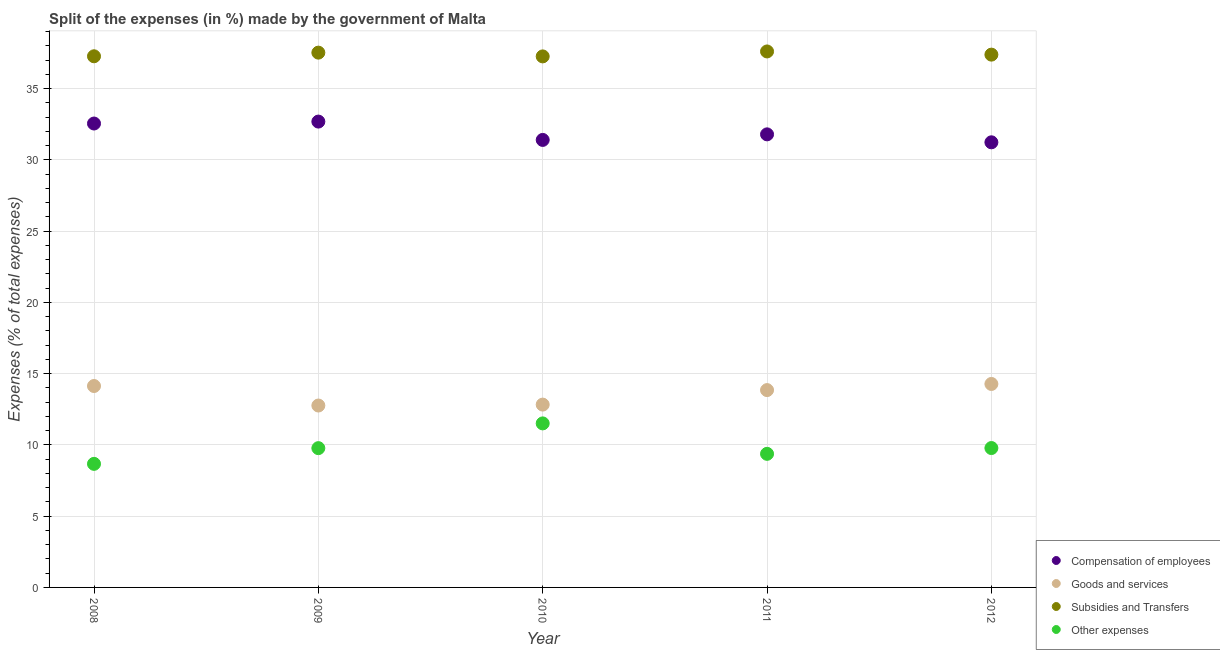How many different coloured dotlines are there?
Offer a terse response. 4. What is the percentage of amount spent on subsidies in 2012?
Provide a short and direct response. 37.38. Across all years, what is the maximum percentage of amount spent on goods and services?
Ensure brevity in your answer.  14.28. Across all years, what is the minimum percentage of amount spent on compensation of employees?
Provide a short and direct response. 31.23. In which year was the percentage of amount spent on subsidies maximum?
Your response must be concise. 2011. What is the total percentage of amount spent on goods and services in the graph?
Offer a very short reply. 67.84. What is the difference between the percentage of amount spent on goods and services in 2010 and that in 2012?
Keep it short and to the point. -1.45. What is the difference between the percentage of amount spent on subsidies in 2008 and the percentage of amount spent on other expenses in 2009?
Keep it short and to the point. 27.49. What is the average percentage of amount spent on compensation of employees per year?
Provide a succinct answer. 31.93. In the year 2011, what is the difference between the percentage of amount spent on other expenses and percentage of amount spent on goods and services?
Ensure brevity in your answer.  -4.47. What is the ratio of the percentage of amount spent on other expenses in 2008 to that in 2011?
Offer a terse response. 0.93. Is the percentage of amount spent on goods and services in 2008 less than that in 2012?
Your answer should be compact. Yes. Is the difference between the percentage of amount spent on compensation of employees in 2008 and 2009 greater than the difference between the percentage of amount spent on subsidies in 2008 and 2009?
Give a very brief answer. Yes. What is the difference between the highest and the second highest percentage of amount spent on other expenses?
Keep it short and to the point. 1.73. What is the difference between the highest and the lowest percentage of amount spent on subsidies?
Ensure brevity in your answer.  0.35. How many years are there in the graph?
Provide a short and direct response. 5. Does the graph contain grids?
Offer a terse response. Yes. What is the title of the graph?
Give a very brief answer. Split of the expenses (in %) made by the government of Malta. What is the label or title of the Y-axis?
Make the answer very short. Expenses (% of total expenses). What is the Expenses (% of total expenses) in Compensation of employees in 2008?
Offer a very short reply. 32.55. What is the Expenses (% of total expenses) in Goods and services in 2008?
Offer a terse response. 14.13. What is the Expenses (% of total expenses) in Subsidies and Transfers in 2008?
Ensure brevity in your answer.  37.27. What is the Expenses (% of total expenses) of Other expenses in 2008?
Your answer should be compact. 8.67. What is the Expenses (% of total expenses) in Compensation of employees in 2009?
Provide a succinct answer. 32.69. What is the Expenses (% of total expenses) of Goods and services in 2009?
Provide a succinct answer. 12.76. What is the Expenses (% of total expenses) in Subsidies and Transfers in 2009?
Provide a succinct answer. 37.52. What is the Expenses (% of total expenses) in Other expenses in 2009?
Your answer should be very brief. 9.77. What is the Expenses (% of total expenses) in Compensation of employees in 2010?
Provide a succinct answer. 31.4. What is the Expenses (% of total expenses) in Goods and services in 2010?
Offer a very short reply. 12.83. What is the Expenses (% of total expenses) in Subsidies and Transfers in 2010?
Ensure brevity in your answer.  37.26. What is the Expenses (% of total expenses) of Other expenses in 2010?
Provide a succinct answer. 11.51. What is the Expenses (% of total expenses) in Compensation of employees in 2011?
Provide a short and direct response. 31.79. What is the Expenses (% of total expenses) in Goods and services in 2011?
Give a very brief answer. 13.85. What is the Expenses (% of total expenses) of Subsidies and Transfers in 2011?
Your answer should be very brief. 37.61. What is the Expenses (% of total expenses) of Other expenses in 2011?
Ensure brevity in your answer.  9.37. What is the Expenses (% of total expenses) of Compensation of employees in 2012?
Provide a short and direct response. 31.23. What is the Expenses (% of total expenses) of Goods and services in 2012?
Ensure brevity in your answer.  14.28. What is the Expenses (% of total expenses) in Subsidies and Transfers in 2012?
Your answer should be compact. 37.38. What is the Expenses (% of total expenses) in Other expenses in 2012?
Offer a very short reply. 9.78. Across all years, what is the maximum Expenses (% of total expenses) of Compensation of employees?
Give a very brief answer. 32.69. Across all years, what is the maximum Expenses (% of total expenses) of Goods and services?
Provide a succinct answer. 14.28. Across all years, what is the maximum Expenses (% of total expenses) in Subsidies and Transfers?
Provide a succinct answer. 37.61. Across all years, what is the maximum Expenses (% of total expenses) in Other expenses?
Ensure brevity in your answer.  11.51. Across all years, what is the minimum Expenses (% of total expenses) in Compensation of employees?
Your answer should be very brief. 31.23. Across all years, what is the minimum Expenses (% of total expenses) of Goods and services?
Give a very brief answer. 12.76. Across all years, what is the minimum Expenses (% of total expenses) of Subsidies and Transfers?
Offer a terse response. 37.26. Across all years, what is the minimum Expenses (% of total expenses) of Other expenses?
Ensure brevity in your answer.  8.67. What is the total Expenses (% of total expenses) of Compensation of employees in the graph?
Make the answer very short. 159.65. What is the total Expenses (% of total expenses) of Goods and services in the graph?
Provide a short and direct response. 67.84. What is the total Expenses (% of total expenses) in Subsidies and Transfers in the graph?
Keep it short and to the point. 187.04. What is the total Expenses (% of total expenses) of Other expenses in the graph?
Your answer should be very brief. 49.1. What is the difference between the Expenses (% of total expenses) of Compensation of employees in 2008 and that in 2009?
Offer a very short reply. -0.14. What is the difference between the Expenses (% of total expenses) of Goods and services in 2008 and that in 2009?
Your answer should be very brief. 1.37. What is the difference between the Expenses (% of total expenses) of Subsidies and Transfers in 2008 and that in 2009?
Offer a terse response. -0.26. What is the difference between the Expenses (% of total expenses) in Other expenses in 2008 and that in 2009?
Offer a terse response. -1.1. What is the difference between the Expenses (% of total expenses) in Compensation of employees in 2008 and that in 2010?
Make the answer very short. 1.15. What is the difference between the Expenses (% of total expenses) of Goods and services in 2008 and that in 2010?
Your response must be concise. 1.3. What is the difference between the Expenses (% of total expenses) of Subsidies and Transfers in 2008 and that in 2010?
Make the answer very short. 0.01. What is the difference between the Expenses (% of total expenses) in Other expenses in 2008 and that in 2010?
Your answer should be compact. -2.84. What is the difference between the Expenses (% of total expenses) in Compensation of employees in 2008 and that in 2011?
Keep it short and to the point. 0.76. What is the difference between the Expenses (% of total expenses) in Goods and services in 2008 and that in 2011?
Make the answer very short. 0.29. What is the difference between the Expenses (% of total expenses) of Subsidies and Transfers in 2008 and that in 2011?
Make the answer very short. -0.34. What is the difference between the Expenses (% of total expenses) of Other expenses in 2008 and that in 2011?
Provide a succinct answer. -0.7. What is the difference between the Expenses (% of total expenses) of Compensation of employees in 2008 and that in 2012?
Make the answer very short. 1.32. What is the difference between the Expenses (% of total expenses) of Goods and services in 2008 and that in 2012?
Offer a very short reply. -0.14. What is the difference between the Expenses (% of total expenses) in Subsidies and Transfers in 2008 and that in 2012?
Offer a terse response. -0.12. What is the difference between the Expenses (% of total expenses) in Other expenses in 2008 and that in 2012?
Give a very brief answer. -1.11. What is the difference between the Expenses (% of total expenses) in Compensation of employees in 2009 and that in 2010?
Provide a succinct answer. 1.29. What is the difference between the Expenses (% of total expenses) of Goods and services in 2009 and that in 2010?
Offer a very short reply. -0.06. What is the difference between the Expenses (% of total expenses) in Subsidies and Transfers in 2009 and that in 2010?
Your answer should be compact. 0.26. What is the difference between the Expenses (% of total expenses) in Other expenses in 2009 and that in 2010?
Provide a short and direct response. -1.74. What is the difference between the Expenses (% of total expenses) of Compensation of employees in 2009 and that in 2011?
Your answer should be very brief. 0.9. What is the difference between the Expenses (% of total expenses) in Goods and services in 2009 and that in 2011?
Provide a succinct answer. -1.08. What is the difference between the Expenses (% of total expenses) of Subsidies and Transfers in 2009 and that in 2011?
Make the answer very short. -0.08. What is the difference between the Expenses (% of total expenses) in Other expenses in 2009 and that in 2011?
Give a very brief answer. 0.4. What is the difference between the Expenses (% of total expenses) of Compensation of employees in 2009 and that in 2012?
Your response must be concise. 1.45. What is the difference between the Expenses (% of total expenses) of Goods and services in 2009 and that in 2012?
Make the answer very short. -1.51. What is the difference between the Expenses (% of total expenses) of Subsidies and Transfers in 2009 and that in 2012?
Make the answer very short. 0.14. What is the difference between the Expenses (% of total expenses) of Other expenses in 2009 and that in 2012?
Offer a very short reply. -0.01. What is the difference between the Expenses (% of total expenses) in Compensation of employees in 2010 and that in 2011?
Offer a very short reply. -0.39. What is the difference between the Expenses (% of total expenses) of Goods and services in 2010 and that in 2011?
Provide a short and direct response. -1.02. What is the difference between the Expenses (% of total expenses) of Subsidies and Transfers in 2010 and that in 2011?
Your response must be concise. -0.35. What is the difference between the Expenses (% of total expenses) in Other expenses in 2010 and that in 2011?
Your answer should be compact. 2.14. What is the difference between the Expenses (% of total expenses) of Compensation of employees in 2010 and that in 2012?
Make the answer very short. 0.17. What is the difference between the Expenses (% of total expenses) in Goods and services in 2010 and that in 2012?
Make the answer very short. -1.45. What is the difference between the Expenses (% of total expenses) of Subsidies and Transfers in 2010 and that in 2012?
Offer a terse response. -0.12. What is the difference between the Expenses (% of total expenses) in Other expenses in 2010 and that in 2012?
Make the answer very short. 1.73. What is the difference between the Expenses (% of total expenses) in Compensation of employees in 2011 and that in 2012?
Your answer should be very brief. 0.56. What is the difference between the Expenses (% of total expenses) in Goods and services in 2011 and that in 2012?
Offer a terse response. -0.43. What is the difference between the Expenses (% of total expenses) of Subsidies and Transfers in 2011 and that in 2012?
Keep it short and to the point. 0.22. What is the difference between the Expenses (% of total expenses) in Other expenses in 2011 and that in 2012?
Keep it short and to the point. -0.41. What is the difference between the Expenses (% of total expenses) in Compensation of employees in 2008 and the Expenses (% of total expenses) in Goods and services in 2009?
Your response must be concise. 19.79. What is the difference between the Expenses (% of total expenses) of Compensation of employees in 2008 and the Expenses (% of total expenses) of Subsidies and Transfers in 2009?
Your answer should be very brief. -4.97. What is the difference between the Expenses (% of total expenses) in Compensation of employees in 2008 and the Expenses (% of total expenses) in Other expenses in 2009?
Provide a succinct answer. 22.78. What is the difference between the Expenses (% of total expenses) of Goods and services in 2008 and the Expenses (% of total expenses) of Subsidies and Transfers in 2009?
Provide a succinct answer. -23.39. What is the difference between the Expenses (% of total expenses) of Goods and services in 2008 and the Expenses (% of total expenses) of Other expenses in 2009?
Give a very brief answer. 4.36. What is the difference between the Expenses (% of total expenses) of Subsidies and Transfers in 2008 and the Expenses (% of total expenses) of Other expenses in 2009?
Offer a terse response. 27.49. What is the difference between the Expenses (% of total expenses) in Compensation of employees in 2008 and the Expenses (% of total expenses) in Goods and services in 2010?
Your answer should be compact. 19.72. What is the difference between the Expenses (% of total expenses) in Compensation of employees in 2008 and the Expenses (% of total expenses) in Subsidies and Transfers in 2010?
Provide a short and direct response. -4.71. What is the difference between the Expenses (% of total expenses) in Compensation of employees in 2008 and the Expenses (% of total expenses) in Other expenses in 2010?
Make the answer very short. 21.04. What is the difference between the Expenses (% of total expenses) in Goods and services in 2008 and the Expenses (% of total expenses) in Subsidies and Transfers in 2010?
Offer a terse response. -23.13. What is the difference between the Expenses (% of total expenses) of Goods and services in 2008 and the Expenses (% of total expenses) of Other expenses in 2010?
Provide a succinct answer. 2.62. What is the difference between the Expenses (% of total expenses) in Subsidies and Transfers in 2008 and the Expenses (% of total expenses) in Other expenses in 2010?
Ensure brevity in your answer.  25.76. What is the difference between the Expenses (% of total expenses) in Compensation of employees in 2008 and the Expenses (% of total expenses) in Goods and services in 2011?
Make the answer very short. 18.7. What is the difference between the Expenses (% of total expenses) of Compensation of employees in 2008 and the Expenses (% of total expenses) of Subsidies and Transfers in 2011?
Make the answer very short. -5.06. What is the difference between the Expenses (% of total expenses) in Compensation of employees in 2008 and the Expenses (% of total expenses) in Other expenses in 2011?
Provide a short and direct response. 23.18. What is the difference between the Expenses (% of total expenses) of Goods and services in 2008 and the Expenses (% of total expenses) of Subsidies and Transfers in 2011?
Give a very brief answer. -23.47. What is the difference between the Expenses (% of total expenses) of Goods and services in 2008 and the Expenses (% of total expenses) of Other expenses in 2011?
Make the answer very short. 4.76. What is the difference between the Expenses (% of total expenses) of Subsidies and Transfers in 2008 and the Expenses (% of total expenses) of Other expenses in 2011?
Provide a short and direct response. 27.89. What is the difference between the Expenses (% of total expenses) of Compensation of employees in 2008 and the Expenses (% of total expenses) of Goods and services in 2012?
Provide a short and direct response. 18.27. What is the difference between the Expenses (% of total expenses) of Compensation of employees in 2008 and the Expenses (% of total expenses) of Subsidies and Transfers in 2012?
Ensure brevity in your answer.  -4.83. What is the difference between the Expenses (% of total expenses) of Compensation of employees in 2008 and the Expenses (% of total expenses) of Other expenses in 2012?
Your answer should be compact. 22.77. What is the difference between the Expenses (% of total expenses) of Goods and services in 2008 and the Expenses (% of total expenses) of Subsidies and Transfers in 2012?
Provide a succinct answer. -23.25. What is the difference between the Expenses (% of total expenses) in Goods and services in 2008 and the Expenses (% of total expenses) in Other expenses in 2012?
Provide a short and direct response. 4.35. What is the difference between the Expenses (% of total expenses) of Subsidies and Transfers in 2008 and the Expenses (% of total expenses) of Other expenses in 2012?
Keep it short and to the point. 27.49. What is the difference between the Expenses (% of total expenses) of Compensation of employees in 2009 and the Expenses (% of total expenses) of Goods and services in 2010?
Offer a terse response. 19.86. What is the difference between the Expenses (% of total expenses) of Compensation of employees in 2009 and the Expenses (% of total expenses) of Subsidies and Transfers in 2010?
Offer a terse response. -4.57. What is the difference between the Expenses (% of total expenses) in Compensation of employees in 2009 and the Expenses (% of total expenses) in Other expenses in 2010?
Provide a short and direct response. 21.18. What is the difference between the Expenses (% of total expenses) in Goods and services in 2009 and the Expenses (% of total expenses) in Subsidies and Transfers in 2010?
Provide a short and direct response. -24.5. What is the difference between the Expenses (% of total expenses) in Goods and services in 2009 and the Expenses (% of total expenses) in Other expenses in 2010?
Your answer should be very brief. 1.25. What is the difference between the Expenses (% of total expenses) in Subsidies and Transfers in 2009 and the Expenses (% of total expenses) in Other expenses in 2010?
Your answer should be very brief. 26.01. What is the difference between the Expenses (% of total expenses) of Compensation of employees in 2009 and the Expenses (% of total expenses) of Goods and services in 2011?
Keep it short and to the point. 18.84. What is the difference between the Expenses (% of total expenses) in Compensation of employees in 2009 and the Expenses (% of total expenses) in Subsidies and Transfers in 2011?
Ensure brevity in your answer.  -4.92. What is the difference between the Expenses (% of total expenses) in Compensation of employees in 2009 and the Expenses (% of total expenses) in Other expenses in 2011?
Make the answer very short. 23.31. What is the difference between the Expenses (% of total expenses) in Goods and services in 2009 and the Expenses (% of total expenses) in Subsidies and Transfers in 2011?
Provide a short and direct response. -24.84. What is the difference between the Expenses (% of total expenses) of Goods and services in 2009 and the Expenses (% of total expenses) of Other expenses in 2011?
Make the answer very short. 3.39. What is the difference between the Expenses (% of total expenses) in Subsidies and Transfers in 2009 and the Expenses (% of total expenses) in Other expenses in 2011?
Make the answer very short. 28.15. What is the difference between the Expenses (% of total expenses) of Compensation of employees in 2009 and the Expenses (% of total expenses) of Goods and services in 2012?
Offer a terse response. 18.41. What is the difference between the Expenses (% of total expenses) of Compensation of employees in 2009 and the Expenses (% of total expenses) of Subsidies and Transfers in 2012?
Provide a succinct answer. -4.7. What is the difference between the Expenses (% of total expenses) of Compensation of employees in 2009 and the Expenses (% of total expenses) of Other expenses in 2012?
Make the answer very short. 22.91. What is the difference between the Expenses (% of total expenses) of Goods and services in 2009 and the Expenses (% of total expenses) of Subsidies and Transfers in 2012?
Your answer should be very brief. -24.62. What is the difference between the Expenses (% of total expenses) of Goods and services in 2009 and the Expenses (% of total expenses) of Other expenses in 2012?
Ensure brevity in your answer.  2.98. What is the difference between the Expenses (% of total expenses) of Subsidies and Transfers in 2009 and the Expenses (% of total expenses) of Other expenses in 2012?
Make the answer very short. 27.74. What is the difference between the Expenses (% of total expenses) of Compensation of employees in 2010 and the Expenses (% of total expenses) of Goods and services in 2011?
Your response must be concise. 17.55. What is the difference between the Expenses (% of total expenses) in Compensation of employees in 2010 and the Expenses (% of total expenses) in Subsidies and Transfers in 2011?
Provide a succinct answer. -6.21. What is the difference between the Expenses (% of total expenses) in Compensation of employees in 2010 and the Expenses (% of total expenses) in Other expenses in 2011?
Your answer should be compact. 22.03. What is the difference between the Expenses (% of total expenses) of Goods and services in 2010 and the Expenses (% of total expenses) of Subsidies and Transfers in 2011?
Make the answer very short. -24.78. What is the difference between the Expenses (% of total expenses) of Goods and services in 2010 and the Expenses (% of total expenses) of Other expenses in 2011?
Your answer should be compact. 3.45. What is the difference between the Expenses (% of total expenses) of Subsidies and Transfers in 2010 and the Expenses (% of total expenses) of Other expenses in 2011?
Provide a short and direct response. 27.89. What is the difference between the Expenses (% of total expenses) of Compensation of employees in 2010 and the Expenses (% of total expenses) of Goods and services in 2012?
Provide a succinct answer. 17.12. What is the difference between the Expenses (% of total expenses) of Compensation of employees in 2010 and the Expenses (% of total expenses) of Subsidies and Transfers in 2012?
Provide a short and direct response. -5.98. What is the difference between the Expenses (% of total expenses) of Compensation of employees in 2010 and the Expenses (% of total expenses) of Other expenses in 2012?
Your response must be concise. 21.62. What is the difference between the Expenses (% of total expenses) in Goods and services in 2010 and the Expenses (% of total expenses) in Subsidies and Transfers in 2012?
Your answer should be compact. -24.55. What is the difference between the Expenses (% of total expenses) of Goods and services in 2010 and the Expenses (% of total expenses) of Other expenses in 2012?
Ensure brevity in your answer.  3.05. What is the difference between the Expenses (% of total expenses) in Subsidies and Transfers in 2010 and the Expenses (% of total expenses) in Other expenses in 2012?
Keep it short and to the point. 27.48. What is the difference between the Expenses (% of total expenses) of Compensation of employees in 2011 and the Expenses (% of total expenses) of Goods and services in 2012?
Offer a very short reply. 17.51. What is the difference between the Expenses (% of total expenses) of Compensation of employees in 2011 and the Expenses (% of total expenses) of Subsidies and Transfers in 2012?
Your response must be concise. -5.59. What is the difference between the Expenses (% of total expenses) in Compensation of employees in 2011 and the Expenses (% of total expenses) in Other expenses in 2012?
Keep it short and to the point. 22.01. What is the difference between the Expenses (% of total expenses) of Goods and services in 2011 and the Expenses (% of total expenses) of Subsidies and Transfers in 2012?
Provide a succinct answer. -23.54. What is the difference between the Expenses (% of total expenses) of Goods and services in 2011 and the Expenses (% of total expenses) of Other expenses in 2012?
Ensure brevity in your answer.  4.07. What is the difference between the Expenses (% of total expenses) in Subsidies and Transfers in 2011 and the Expenses (% of total expenses) in Other expenses in 2012?
Offer a very short reply. 27.83. What is the average Expenses (% of total expenses) of Compensation of employees per year?
Your response must be concise. 31.93. What is the average Expenses (% of total expenses) in Goods and services per year?
Make the answer very short. 13.57. What is the average Expenses (% of total expenses) in Subsidies and Transfers per year?
Keep it short and to the point. 37.41. What is the average Expenses (% of total expenses) of Other expenses per year?
Your answer should be compact. 9.82. In the year 2008, what is the difference between the Expenses (% of total expenses) in Compensation of employees and Expenses (% of total expenses) in Goods and services?
Provide a succinct answer. 18.42. In the year 2008, what is the difference between the Expenses (% of total expenses) of Compensation of employees and Expenses (% of total expenses) of Subsidies and Transfers?
Your answer should be compact. -4.72. In the year 2008, what is the difference between the Expenses (% of total expenses) in Compensation of employees and Expenses (% of total expenses) in Other expenses?
Provide a short and direct response. 23.88. In the year 2008, what is the difference between the Expenses (% of total expenses) of Goods and services and Expenses (% of total expenses) of Subsidies and Transfers?
Ensure brevity in your answer.  -23.14. In the year 2008, what is the difference between the Expenses (% of total expenses) of Goods and services and Expenses (% of total expenses) of Other expenses?
Give a very brief answer. 5.46. In the year 2008, what is the difference between the Expenses (% of total expenses) of Subsidies and Transfers and Expenses (% of total expenses) of Other expenses?
Provide a succinct answer. 28.6. In the year 2009, what is the difference between the Expenses (% of total expenses) of Compensation of employees and Expenses (% of total expenses) of Goods and services?
Make the answer very short. 19.92. In the year 2009, what is the difference between the Expenses (% of total expenses) in Compensation of employees and Expenses (% of total expenses) in Subsidies and Transfers?
Ensure brevity in your answer.  -4.84. In the year 2009, what is the difference between the Expenses (% of total expenses) in Compensation of employees and Expenses (% of total expenses) in Other expenses?
Make the answer very short. 22.91. In the year 2009, what is the difference between the Expenses (% of total expenses) of Goods and services and Expenses (% of total expenses) of Subsidies and Transfers?
Ensure brevity in your answer.  -24.76. In the year 2009, what is the difference between the Expenses (% of total expenses) of Goods and services and Expenses (% of total expenses) of Other expenses?
Make the answer very short. 2.99. In the year 2009, what is the difference between the Expenses (% of total expenses) of Subsidies and Transfers and Expenses (% of total expenses) of Other expenses?
Your response must be concise. 27.75. In the year 2010, what is the difference between the Expenses (% of total expenses) in Compensation of employees and Expenses (% of total expenses) in Goods and services?
Give a very brief answer. 18.57. In the year 2010, what is the difference between the Expenses (% of total expenses) in Compensation of employees and Expenses (% of total expenses) in Subsidies and Transfers?
Give a very brief answer. -5.86. In the year 2010, what is the difference between the Expenses (% of total expenses) in Compensation of employees and Expenses (% of total expenses) in Other expenses?
Provide a short and direct response. 19.89. In the year 2010, what is the difference between the Expenses (% of total expenses) in Goods and services and Expenses (% of total expenses) in Subsidies and Transfers?
Provide a short and direct response. -24.43. In the year 2010, what is the difference between the Expenses (% of total expenses) in Goods and services and Expenses (% of total expenses) in Other expenses?
Provide a succinct answer. 1.32. In the year 2010, what is the difference between the Expenses (% of total expenses) in Subsidies and Transfers and Expenses (% of total expenses) in Other expenses?
Your answer should be compact. 25.75. In the year 2011, what is the difference between the Expenses (% of total expenses) in Compensation of employees and Expenses (% of total expenses) in Goods and services?
Ensure brevity in your answer.  17.94. In the year 2011, what is the difference between the Expenses (% of total expenses) in Compensation of employees and Expenses (% of total expenses) in Subsidies and Transfers?
Keep it short and to the point. -5.82. In the year 2011, what is the difference between the Expenses (% of total expenses) in Compensation of employees and Expenses (% of total expenses) in Other expenses?
Ensure brevity in your answer.  22.42. In the year 2011, what is the difference between the Expenses (% of total expenses) in Goods and services and Expenses (% of total expenses) in Subsidies and Transfers?
Make the answer very short. -23.76. In the year 2011, what is the difference between the Expenses (% of total expenses) in Goods and services and Expenses (% of total expenses) in Other expenses?
Your answer should be very brief. 4.47. In the year 2011, what is the difference between the Expenses (% of total expenses) of Subsidies and Transfers and Expenses (% of total expenses) of Other expenses?
Keep it short and to the point. 28.23. In the year 2012, what is the difference between the Expenses (% of total expenses) of Compensation of employees and Expenses (% of total expenses) of Goods and services?
Your answer should be compact. 16.96. In the year 2012, what is the difference between the Expenses (% of total expenses) in Compensation of employees and Expenses (% of total expenses) in Subsidies and Transfers?
Your answer should be compact. -6.15. In the year 2012, what is the difference between the Expenses (% of total expenses) in Compensation of employees and Expenses (% of total expenses) in Other expenses?
Provide a short and direct response. 21.45. In the year 2012, what is the difference between the Expenses (% of total expenses) of Goods and services and Expenses (% of total expenses) of Subsidies and Transfers?
Ensure brevity in your answer.  -23.11. In the year 2012, what is the difference between the Expenses (% of total expenses) of Goods and services and Expenses (% of total expenses) of Other expenses?
Provide a succinct answer. 4.5. In the year 2012, what is the difference between the Expenses (% of total expenses) of Subsidies and Transfers and Expenses (% of total expenses) of Other expenses?
Keep it short and to the point. 27.6. What is the ratio of the Expenses (% of total expenses) in Compensation of employees in 2008 to that in 2009?
Provide a short and direct response. 1. What is the ratio of the Expenses (% of total expenses) in Goods and services in 2008 to that in 2009?
Your answer should be compact. 1.11. What is the ratio of the Expenses (% of total expenses) in Other expenses in 2008 to that in 2009?
Offer a very short reply. 0.89. What is the ratio of the Expenses (% of total expenses) of Compensation of employees in 2008 to that in 2010?
Keep it short and to the point. 1.04. What is the ratio of the Expenses (% of total expenses) of Goods and services in 2008 to that in 2010?
Provide a short and direct response. 1.1. What is the ratio of the Expenses (% of total expenses) in Other expenses in 2008 to that in 2010?
Provide a short and direct response. 0.75. What is the ratio of the Expenses (% of total expenses) in Compensation of employees in 2008 to that in 2011?
Your response must be concise. 1.02. What is the ratio of the Expenses (% of total expenses) of Goods and services in 2008 to that in 2011?
Provide a succinct answer. 1.02. What is the ratio of the Expenses (% of total expenses) in Other expenses in 2008 to that in 2011?
Your response must be concise. 0.93. What is the ratio of the Expenses (% of total expenses) in Compensation of employees in 2008 to that in 2012?
Ensure brevity in your answer.  1.04. What is the ratio of the Expenses (% of total expenses) of Other expenses in 2008 to that in 2012?
Give a very brief answer. 0.89. What is the ratio of the Expenses (% of total expenses) in Compensation of employees in 2009 to that in 2010?
Offer a terse response. 1.04. What is the ratio of the Expenses (% of total expenses) in Goods and services in 2009 to that in 2010?
Offer a very short reply. 0.99. What is the ratio of the Expenses (% of total expenses) of Subsidies and Transfers in 2009 to that in 2010?
Provide a succinct answer. 1.01. What is the ratio of the Expenses (% of total expenses) in Other expenses in 2009 to that in 2010?
Offer a very short reply. 0.85. What is the ratio of the Expenses (% of total expenses) of Compensation of employees in 2009 to that in 2011?
Provide a short and direct response. 1.03. What is the ratio of the Expenses (% of total expenses) of Goods and services in 2009 to that in 2011?
Make the answer very short. 0.92. What is the ratio of the Expenses (% of total expenses) in Subsidies and Transfers in 2009 to that in 2011?
Keep it short and to the point. 1. What is the ratio of the Expenses (% of total expenses) of Other expenses in 2009 to that in 2011?
Your answer should be compact. 1.04. What is the ratio of the Expenses (% of total expenses) in Compensation of employees in 2009 to that in 2012?
Ensure brevity in your answer.  1.05. What is the ratio of the Expenses (% of total expenses) in Goods and services in 2009 to that in 2012?
Ensure brevity in your answer.  0.89. What is the ratio of the Expenses (% of total expenses) in Goods and services in 2010 to that in 2011?
Give a very brief answer. 0.93. What is the ratio of the Expenses (% of total expenses) of Other expenses in 2010 to that in 2011?
Provide a short and direct response. 1.23. What is the ratio of the Expenses (% of total expenses) in Compensation of employees in 2010 to that in 2012?
Offer a terse response. 1.01. What is the ratio of the Expenses (% of total expenses) in Goods and services in 2010 to that in 2012?
Give a very brief answer. 0.9. What is the ratio of the Expenses (% of total expenses) of Subsidies and Transfers in 2010 to that in 2012?
Give a very brief answer. 1. What is the ratio of the Expenses (% of total expenses) in Other expenses in 2010 to that in 2012?
Ensure brevity in your answer.  1.18. What is the ratio of the Expenses (% of total expenses) in Compensation of employees in 2011 to that in 2012?
Offer a very short reply. 1.02. What is the ratio of the Expenses (% of total expenses) of Goods and services in 2011 to that in 2012?
Your response must be concise. 0.97. What is the ratio of the Expenses (% of total expenses) of Subsidies and Transfers in 2011 to that in 2012?
Offer a terse response. 1.01. What is the ratio of the Expenses (% of total expenses) of Other expenses in 2011 to that in 2012?
Your response must be concise. 0.96. What is the difference between the highest and the second highest Expenses (% of total expenses) of Compensation of employees?
Your response must be concise. 0.14. What is the difference between the highest and the second highest Expenses (% of total expenses) of Goods and services?
Provide a succinct answer. 0.14. What is the difference between the highest and the second highest Expenses (% of total expenses) in Subsidies and Transfers?
Your answer should be compact. 0.08. What is the difference between the highest and the second highest Expenses (% of total expenses) in Other expenses?
Provide a short and direct response. 1.73. What is the difference between the highest and the lowest Expenses (% of total expenses) of Compensation of employees?
Give a very brief answer. 1.45. What is the difference between the highest and the lowest Expenses (% of total expenses) of Goods and services?
Provide a short and direct response. 1.51. What is the difference between the highest and the lowest Expenses (% of total expenses) of Subsidies and Transfers?
Provide a succinct answer. 0.35. What is the difference between the highest and the lowest Expenses (% of total expenses) in Other expenses?
Provide a succinct answer. 2.84. 